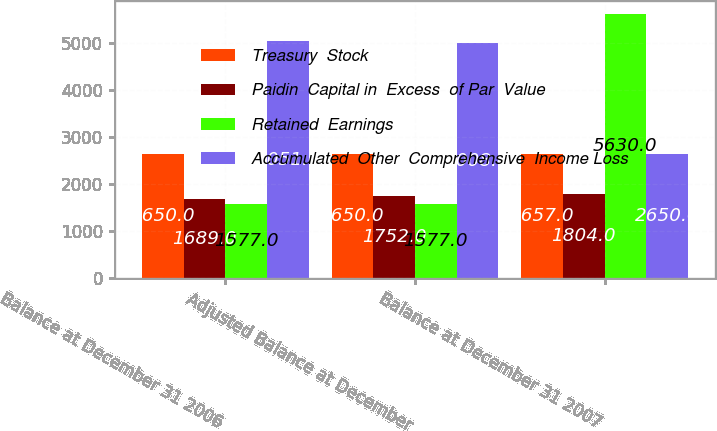<chart> <loc_0><loc_0><loc_500><loc_500><stacked_bar_chart><ecel><fcel>Balance at December 31 2006<fcel>Adjusted Balance at December<fcel>Balance at December 31 2007<nl><fcel>Treasury  Stock<fcel>2650<fcel>2650<fcel>2657<nl><fcel>Paidin  Capital in  Excess  of Par  Value<fcel>1689<fcel>1752<fcel>1804<nl><fcel>Retained  Earnings<fcel>1577<fcel>1577<fcel>5630<nl><fcel>Accumulated  Other  Comprehensive  Income Loss<fcel>5051<fcel>5008<fcel>2650<nl></chart> 